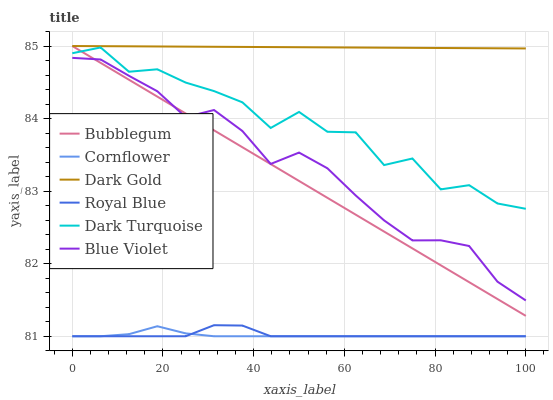Does Cornflower have the minimum area under the curve?
Answer yes or no. Yes. Does Dark Gold have the maximum area under the curve?
Answer yes or no. Yes. Does Dark Turquoise have the minimum area under the curve?
Answer yes or no. No. Does Dark Turquoise have the maximum area under the curve?
Answer yes or no. No. Is Bubblegum the smoothest?
Answer yes or no. Yes. Is Dark Turquoise the roughest?
Answer yes or no. Yes. Is Dark Gold the smoothest?
Answer yes or no. No. Is Dark Gold the roughest?
Answer yes or no. No. Does Cornflower have the lowest value?
Answer yes or no. Yes. Does Dark Turquoise have the lowest value?
Answer yes or no. No. Does Bubblegum have the highest value?
Answer yes or no. Yes. Does Dark Turquoise have the highest value?
Answer yes or no. No. Is Royal Blue less than Dark Turquoise?
Answer yes or no. Yes. Is Blue Violet greater than Royal Blue?
Answer yes or no. Yes. Does Dark Turquoise intersect Bubblegum?
Answer yes or no. Yes. Is Dark Turquoise less than Bubblegum?
Answer yes or no. No. Is Dark Turquoise greater than Bubblegum?
Answer yes or no. No. Does Royal Blue intersect Dark Turquoise?
Answer yes or no. No. 